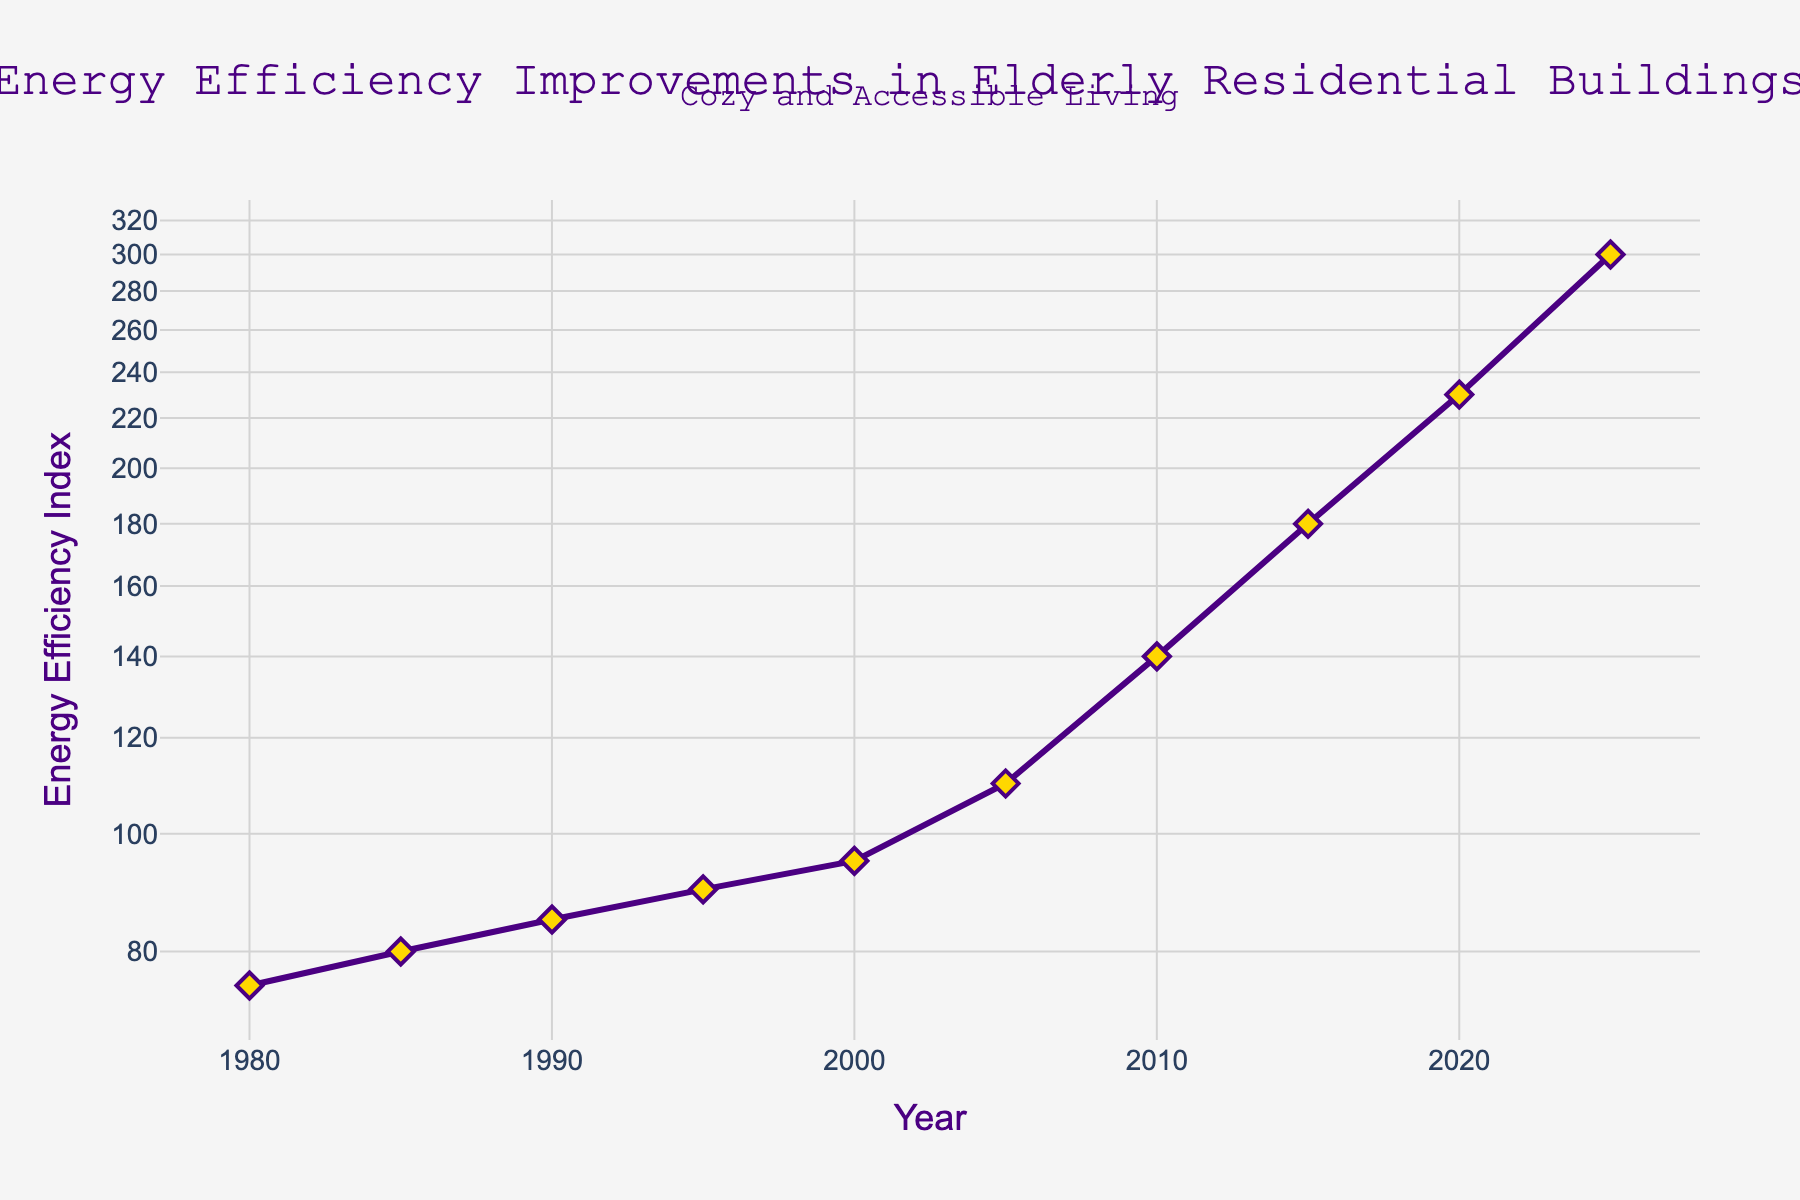What is the title of the plot? The title of the plot is prominently displayed at the top of the figure, giving an overview of the data being presented. The title reads, 'Energy Efficiency Improvements in Elderly Residential Buildings'.
Answer: Energy Efficiency Improvements in Elderly Residential Buildings What is the y-axis label? The y-axis label indicates the metric being measured along the vertical axis. In this plot, it is labeled 'Energy Efficiency Index'.
Answer: Energy Efficiency Index How many data points are shown in the figure? By counting the markers on the line plot, we can determine the number of data points. There are markers for each year, specifically 1980, 1985, 1990, 1995, 2000, 2005, 2010, 2015, 2020, and 2025, totaling to 10 data points.
Answer: 10 What color is the line in the plot? The line color in the plot is indicated by its appearance. In this case, it is a shade of indigo (purple).
Answer: Indigo (purple) Which year shows the highest Energy Efficiency Index? By examining the y-axis values alongside the x-axis, we can determine that the highest data point occurs in the year 2025, with an Energy Efficiency Index of 300.
Answer: 2025 Between which years did the Energy Efficiency Index see the largest increase? We need to compare the differences in the Energy Efficiency Index values between consecutive years. The largest increase is between 2020 (index 230) and 2025 (index 300), which equals a difference of 70.
Answer: 2020 and 2025 What is the approximate Energy Efficiency Index in the year 2010? By locating the point corresponding to the year 2010 on the x-axis and reading the value on the y-axis, we find it approximately at 140.
Answer: 140 How much did the Energy Efficiency Index increase from 1980 to 2000? Subtract the Energy Efficiency Index value in 1980 (75) from that in 2000 (95). The difference is 95 - 75 = 20.
Answer: 20 Which year marked the first time the Energy Efficiency Index exceeded 100? By looking at the Energy Efficiency Index values, we see that 2005 is the first year the index exceeds 100, specifically reaching 110.
Answer: 2005 Is the rate of improvement in Energy Efficiency Index increasing or decreasing over time? To determine this, we observe the plot's slope over different periods. Initially, incremental adjustments are small, but starting around 2000, the improvements become steeper, indicating an increasing rate of improvement over time.
Answer: Increasing 